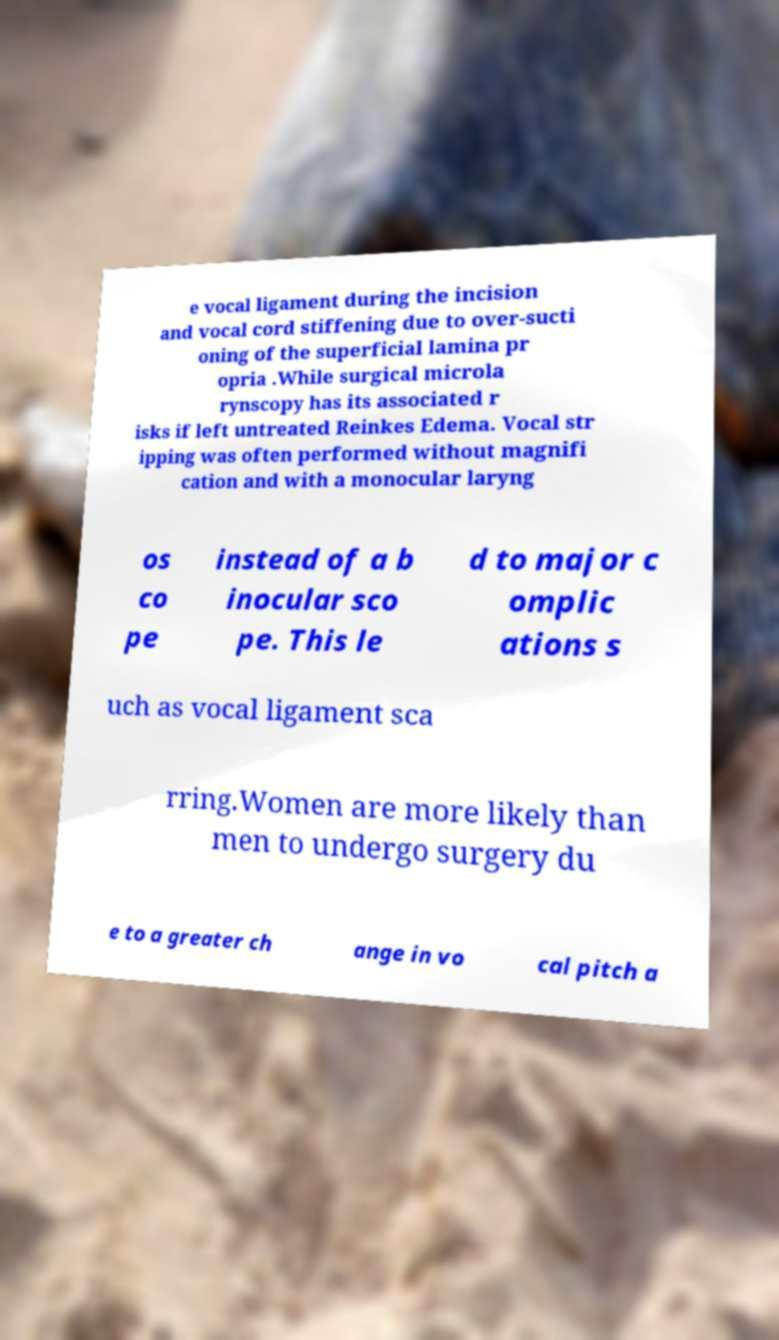What messages or text are displayed in this image? I need them in a readable, typed format. e vocal ligament during the incision and vocal cord stiffening due to over-sucti oning of the superficial lamina pr opria .While surgical microla rynscopy has its associated r isks if left untreated Reinkes Edema. Vocal str ipping was often performed without magnifi cation and with a monocular laryng os co pe instead of a b inocular sco pe. This le d to major c omplic ations s uch as vocal ligament sca rring.Women are more likely than men to undergo surgery du e to a greater ch ange in vo cal pitch a 